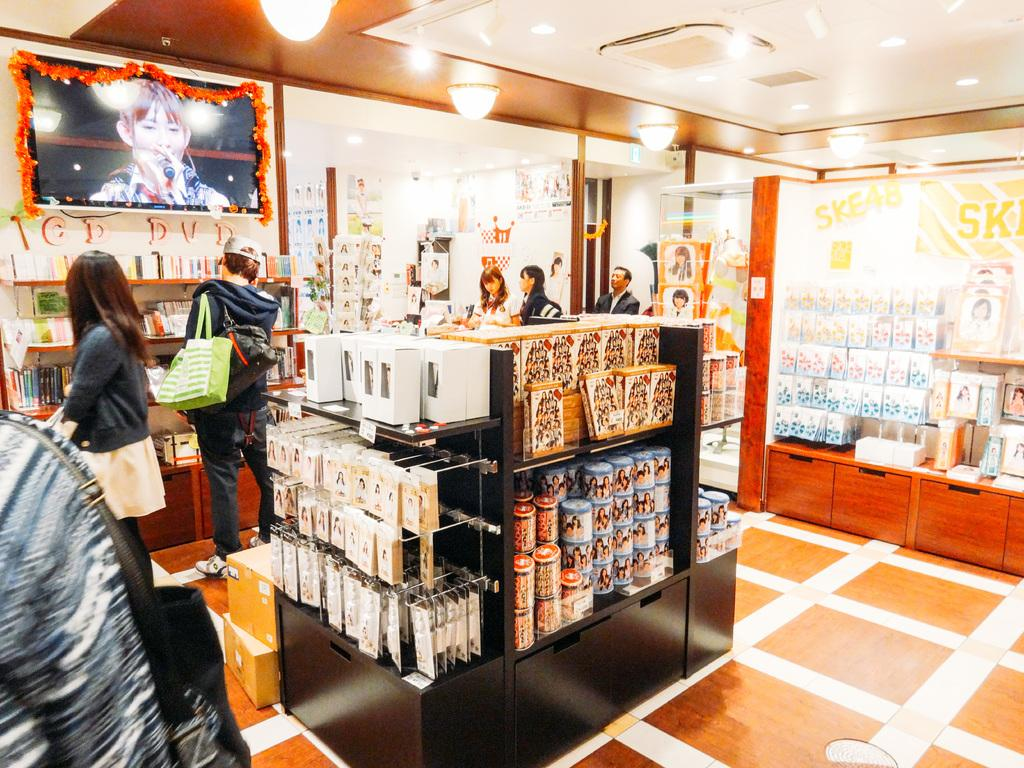What type of furniture is present in the image? There are shelves in the image. What can be found on the shelves? There are things placed on the shelves. Can you describe the people visible in the image? There are people visible in the image. What is on the wall in the image? There is a screen on the wall in the image. What type of record is being played on the shelves in the image? There is no record or record player present in the image. Can you tell me how many boots are visible on the shelves in the image? There are no boots visible on the shelves in the image. 